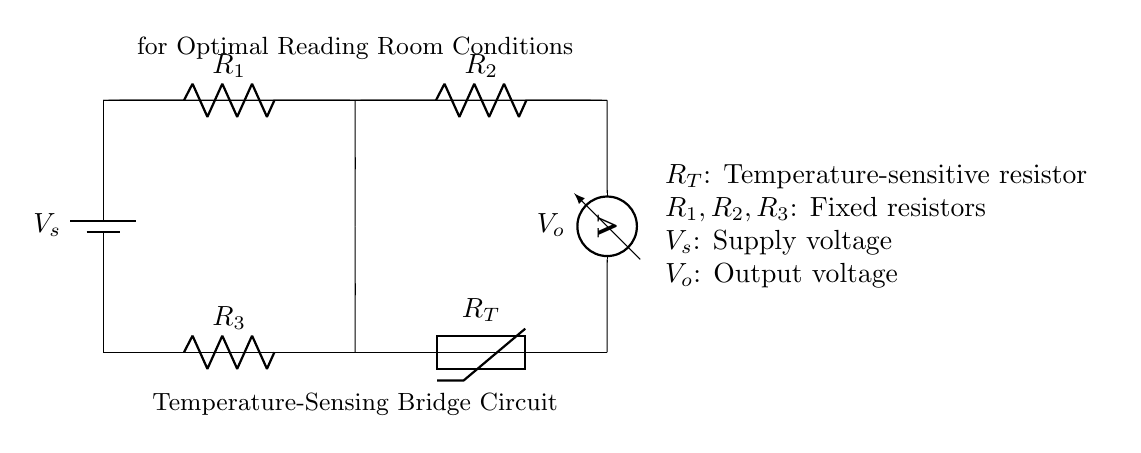What is the supply voltage in this circuit? The supply voltage, labeled as V_s in the diagram, is the voltage provided to the circuit from the battery.
Answer: V_s What type of resistors are used in this circuit? The circuit contains both fixed resistors (R_1, R_2, R_3) and a temperature-sensitive resistor (R_T, the thermistor).
Answer: Fixed and temperature-sensitive What do R_1 and R_2 represent in this circuit? R_1 and R_2 are labeled as resistors in the circuit; they are the fixed resistors that form part of the bridge configuration.
Answer: Fixed resistors What is the role of the thermistor, R_T? The thermistor, R_T, is used to measure temperature changes, affecting the output voltage V_o based on the temperature variation.
Answer: Temperature measurement How does the output voltage V_o relate to the temperature? The output voltage V_o depends on the resistance changes in the thermistor R_T as temperature varies, affecting the voltage division in the bridge.
Answer: Depends on resistance changes What configuration does this circuit use? This circuit utilizes a bridge configuration, where resistors are arranged to form a balanced or unbalanced circuit based on temperature.
Answer: Bridge configuration What component measures the output voltage? The voltmeter, labeled as V_o, measures the output voltage across the circuit and indicates the state based on resistance values.
Answer: Voltmeter 